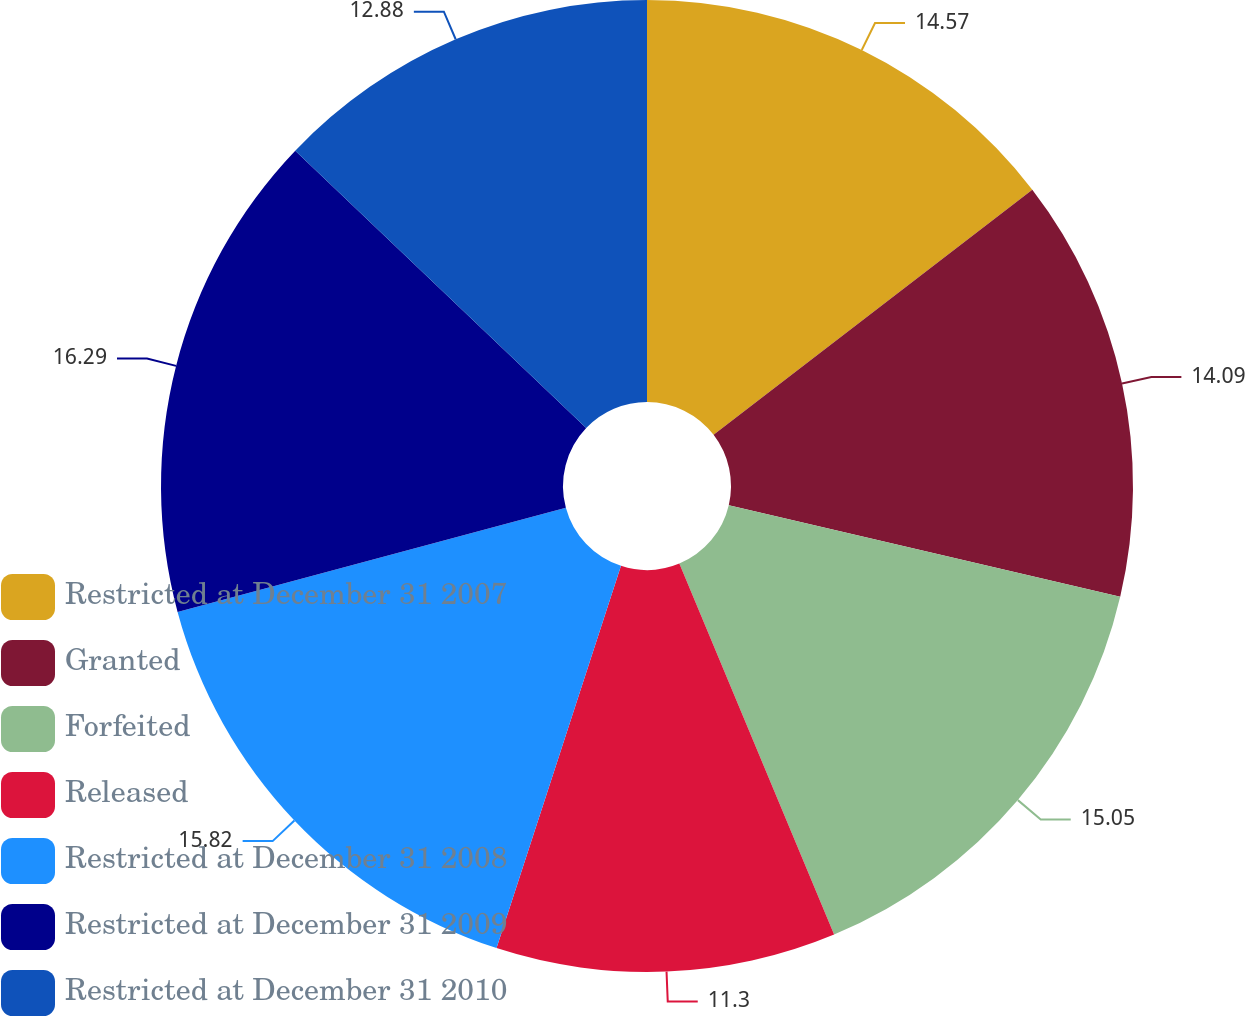Convert chart to OTSL. <chart><loc_0><loc_0><loc_500><loc_500><pie_chart><fcel>Restricted at December 31 2007<fcel>Granted<fcel>Forfeited<fcel>Released<fcel>Restricted at December 31 2008<fcel>Restricted at December 31 2009<fcel>Restricted at December 31 2010<nl><fcel>14.57%<fcel>14.09%<fcel>15.05%<fcel>11.3%<fcel>15.82%<fcel>16.29%<fcel>12.88%<nl></chart> 